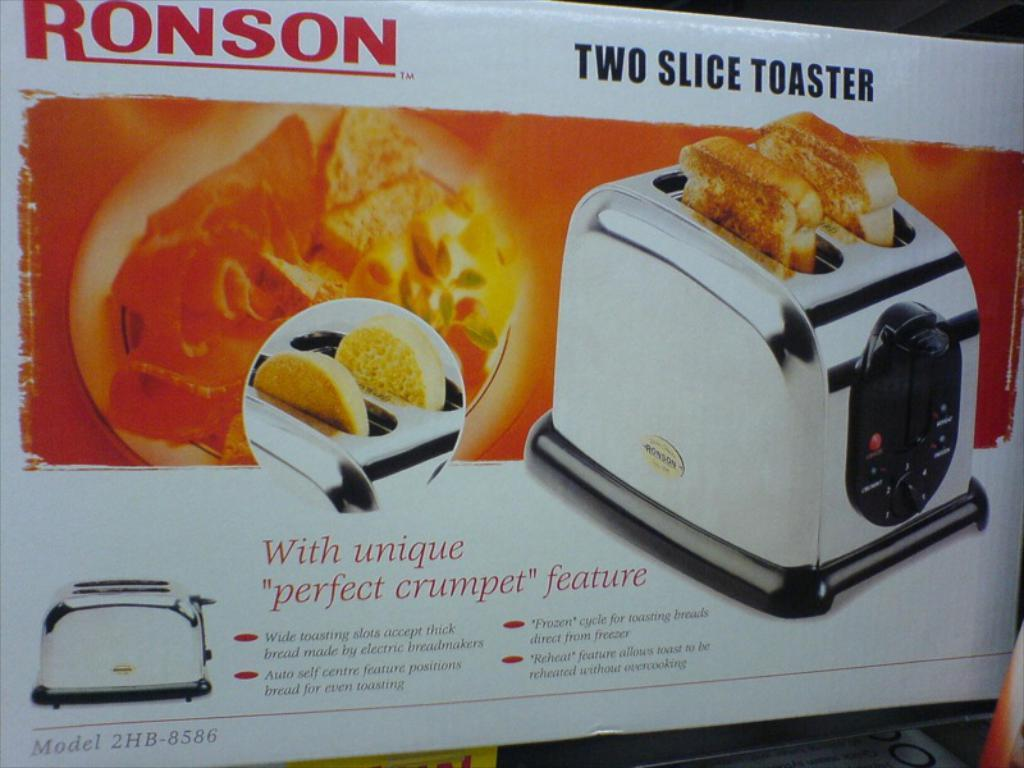Provide a one-sentence caption for the provided image. A two slice toaster oven from the company Ronson. 